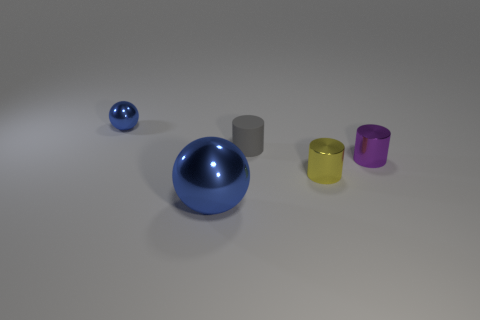Are there any other things that are made of the same material as the small gray cylinder?
Offer a very short reply. No. How many other things are there of the same color as the matte thing?
Keep it short and to the point. 0. There is a gray thing; are there any blue balls behind it?
Your answer should be very brief. Yes. How many objects are either small purple rubber balls or shiny spheres that are behind the purple metal cylinder?
Ensure brevity in your answer.  1. Is there a large blue sphere behind the blue object in front of the small yellow shiny cylinder?
Offer a terse response. No. The gray matte object behind the blue object in front of the ball that is behind the tiny gray cylinder is what shape?
Provide a succinct answer. Cylinder. There is a tiny thing that is both right of the tiny gray rubber thing and on the left side of the purple metallic cylinder; what is its color?
Provide a short and direct response. Yellow. What shape is the tiny object that is in front of the tiny purple metallic cylinder?
Give a very brief answer. Cylinder. There is a small purple object that is the same material as the small blue sphere; what shape is it?
Provide a succinct answer. Cylinder. How many matte objects are either tiny gray cylinders or small yellow objects?
Make the answer very short. 1. 